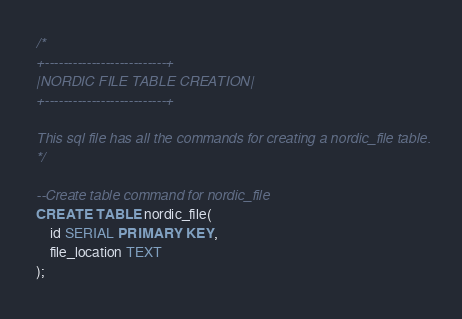Convert code to text. <code><loc_0><loc_0><loc_500><loc_500><_SQL_>/*
+--------------------------+
|NORDIC FILE TABLE CREATION|
+--------------------------+

This sql file has all the commands for creating a nordic_file table.
*/

--Create table command for nordic_file
CREATE TABLE nordic_file(
	id SERIAL PRIMARY KEY,
	file_location TEXT
);
</code> 